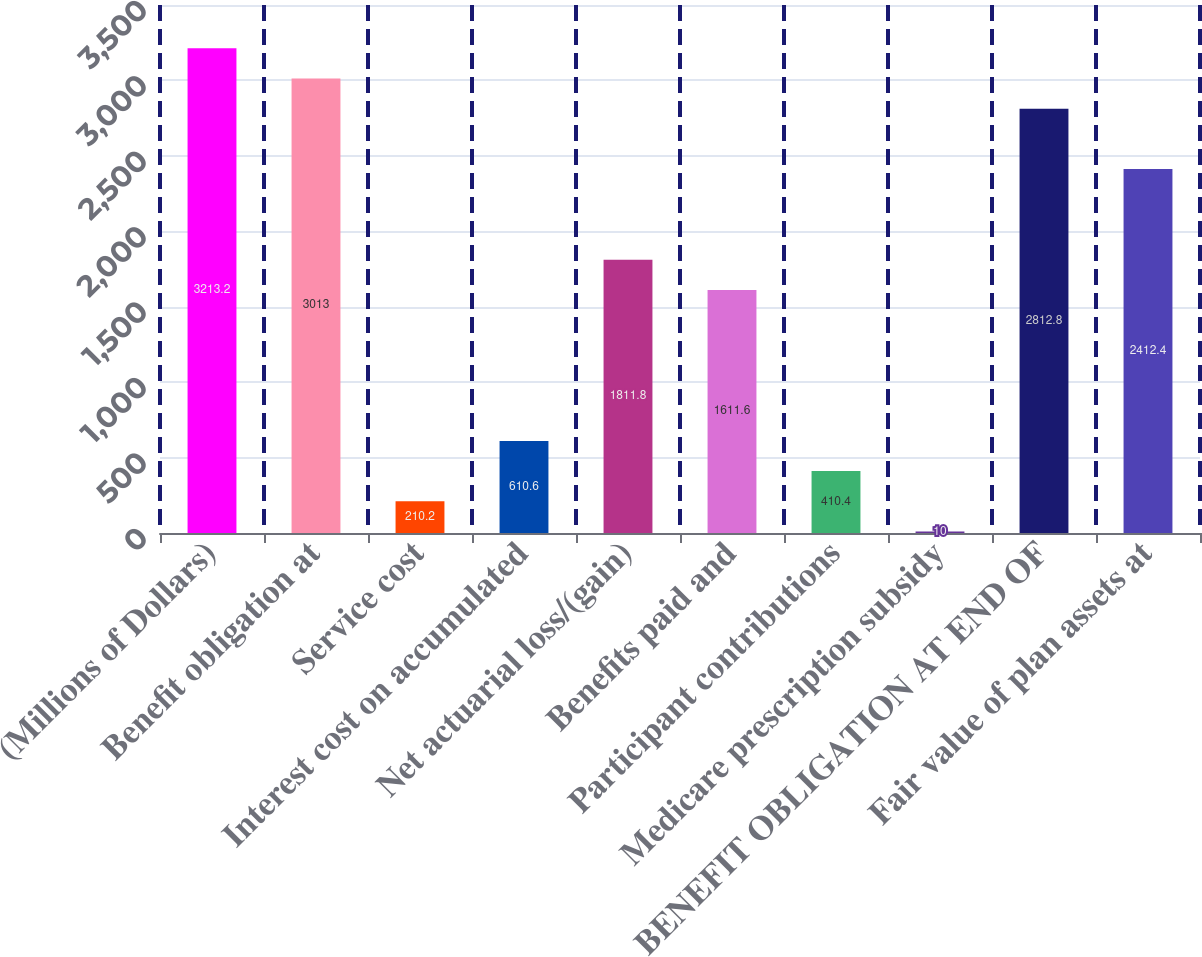Convert chart to OTSL. <chart><loc_0><loc_0><loc_500><loc_500><bar_chart><fcel>(Millions of Dollars)<fcel>Benefit obligation at<fcel>Service cost<fcel>Interest cost on accumulated<fcel>Net actuarial loss/(gain)<fcel>Benefits paid and<fcel>Participant contributions<fcel>Medicare prescription subsidy<fcel>BENEFIT OBLIGATION AT END OF<fcel>Fair value of plan assets at<nl><fcel>3213.2<fcel>3013<fcel>210.2<fcel>610.6<fcel>1811.8<fcel>1611.6<fcel>410.4<fcel>10<fcel>2812.8<fcel>2412.4<nl></chart> 